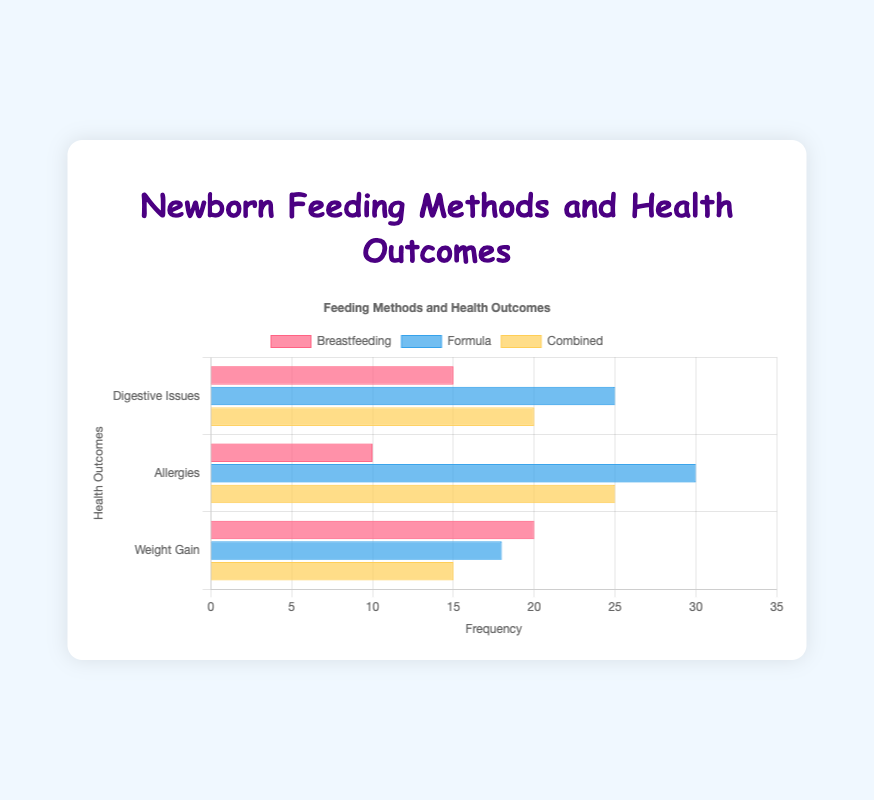What feeding method shows the highest frequency of Digestive Issues? By looking at the height of the bars representing Digestive Issues, Formula shows the highest bar at 25.
Answer: Formula Which health outcome is most frequently reported for Breastfeeding? By comparing the heights of the bars under Breastfeeding, Weight Gain has the highest bar at 20.
Answer: Weight Gain What is the difference in frequency of Allergies between Breastfeeding and Formula? The frequency of Allergies is 10 for Breastfeeding and 30 for Formula. The difference is 30 - 10 = 20.
Answer: 20 What is the total frequency of Weight Gain across all feeding methods? Summing the frequencies for Weight Gain across Breastfeeding (20), Formula (18), and Combined (15) gives 20 + 18 + 15 = 53.
Answer: 53 Which feeding method has the least reported frequency of Weight Gain? By comparing the bars for Weight Gain, Combined has the lowest bar at 15.
Answer: Combined Are Allergies more frequent in Breastfeeding or in Combined feeding method? By comparing the bars representing Allergies, 10 for Breastfeeding and 25 for Combined. Combined is higher.
Answer: Combined What is the average frequency of Digestive Issues across all feeding methods? Adding the frequencies for Digestive Issues across Breastfeeding (15), Formula (25), and Combined (20) gives 15 + 25 + 20 = 60. The average is 60 / 3 = 20.
Answer: 20 Which health outcome has the highest total frequency across all feeding methods? Summing the frequencies for each Health Outcome: Digestive Issues (15+25+20=60), Allergies (10+30+25=65), Weight Gain (20+18+15=53). Allergies have the highest total at 65.
Answer: Allergies How does the frequency of Digestive Issues in Combined feeding compare to that in Formula feeding? The frequency for Digestive Issues in Combined is 20 and in Formula is 25. Combined has 5 less than Formula.
Answer: 5 less What is the total frequency of health outcomes for the Formula feeding method? Adding the frequencies for all health outcomes in Formula: 25 (Digestive Issues) + 30 (Allergies) + 18 (Weight Gain) = 73.
Answer: 73 